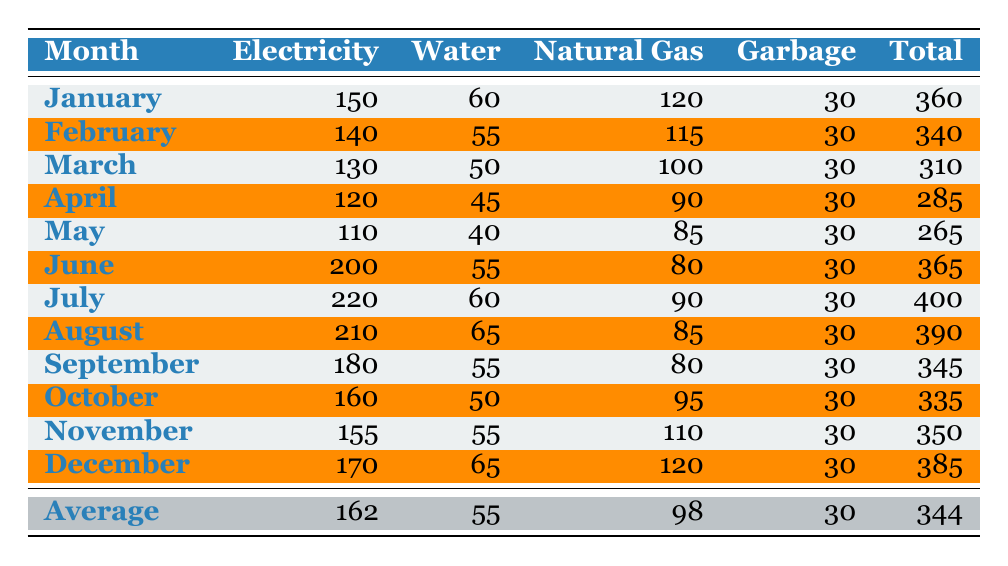What is the total utility cost for December? In the table, the total utility cost for December is directly listed under the "Total" column for that month, which shows 385.
Answer: 385 What month has the highest electricity cost? By looking at the "Electricity" column, July has the highest cost at 220.
Answer: July What is the average cost of water for the year? To find the average water cost, sum all the water costs for each month: (60 + 55 + 50 + 45 + 40 + 55 + 60 + 65 + 55 + 50 + 55 + 65) = 685. There are 12 months, so the average is 685/12 = approximately 57.08, which can be rounded to 57.
Answer: 57 Does the total cost exceed 350 in any month? By inspecting the "Total" column, the values that exceed 350 are January (360), June (365), July (400), August (390), and December (385). Since there are months that exceed 350, the answer is yes.
Answer: Yes In which month was the natural gas cost the lowest? Looking at the "Natural Gas" column, the lowest cost is in May, where it is 85.
Answer: May What is the sum of electricity and water costs for the month of March? For March, the electricity cost is 130 and the water cost is 50. Summing these gives 130 + 50 = 180.
Answer: 180 How much less did the average total cost for the first half of the year compare to the second half? Calculate the average total for the first half (January to June): (360 + 340 + 310 + 285 + 265 + 365) = 1925, average = 1925/6 = approximately 320.83. For the second half (July to December): (400 + 390 + 345 + 335 + 350 + 385) = 2205, average = 2205/6 = approximately 367.5. The difference is 367.5 - 320.83 = approximately 46.67. Approximately, it is a decrease of 47.
Answer: Approximately 47 Which month had the smallest total cost? By examining the "Total" column, we see that May has the smallest total cost at 265.
Answer: May Is the average monthly total cost more than 340? The average monthly total from the "Average" row is 344. Since 344 is greater than 340, the answer is yes.
Answer: Yes What is the difference between the maximum and minimum electricity costs for the year? The maximum electricity cost is 220 in July and the minimum is 110 in May. The difference is calculated as 220 - 110 = 110.
Answer: 110 